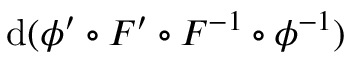<formula> <loc_0><loc_0><loc_500><loc_500>d ( \phi ^ { \prime } \circ F ^ { \prime } \circ F ^ { - 1 } \circ \phi ^ { - 1 } )</formula> 